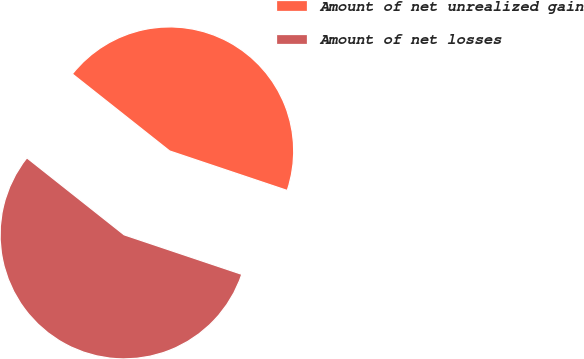Convert chart to OTSL. <chart><loc_0><loc_0><loc_500><loc_500><pie_chart><fcel>Amount of net unrealized gain<fcel>Amount of net losses<nl><fcel>44.5%<fcel>55.5%<nl></chart> 